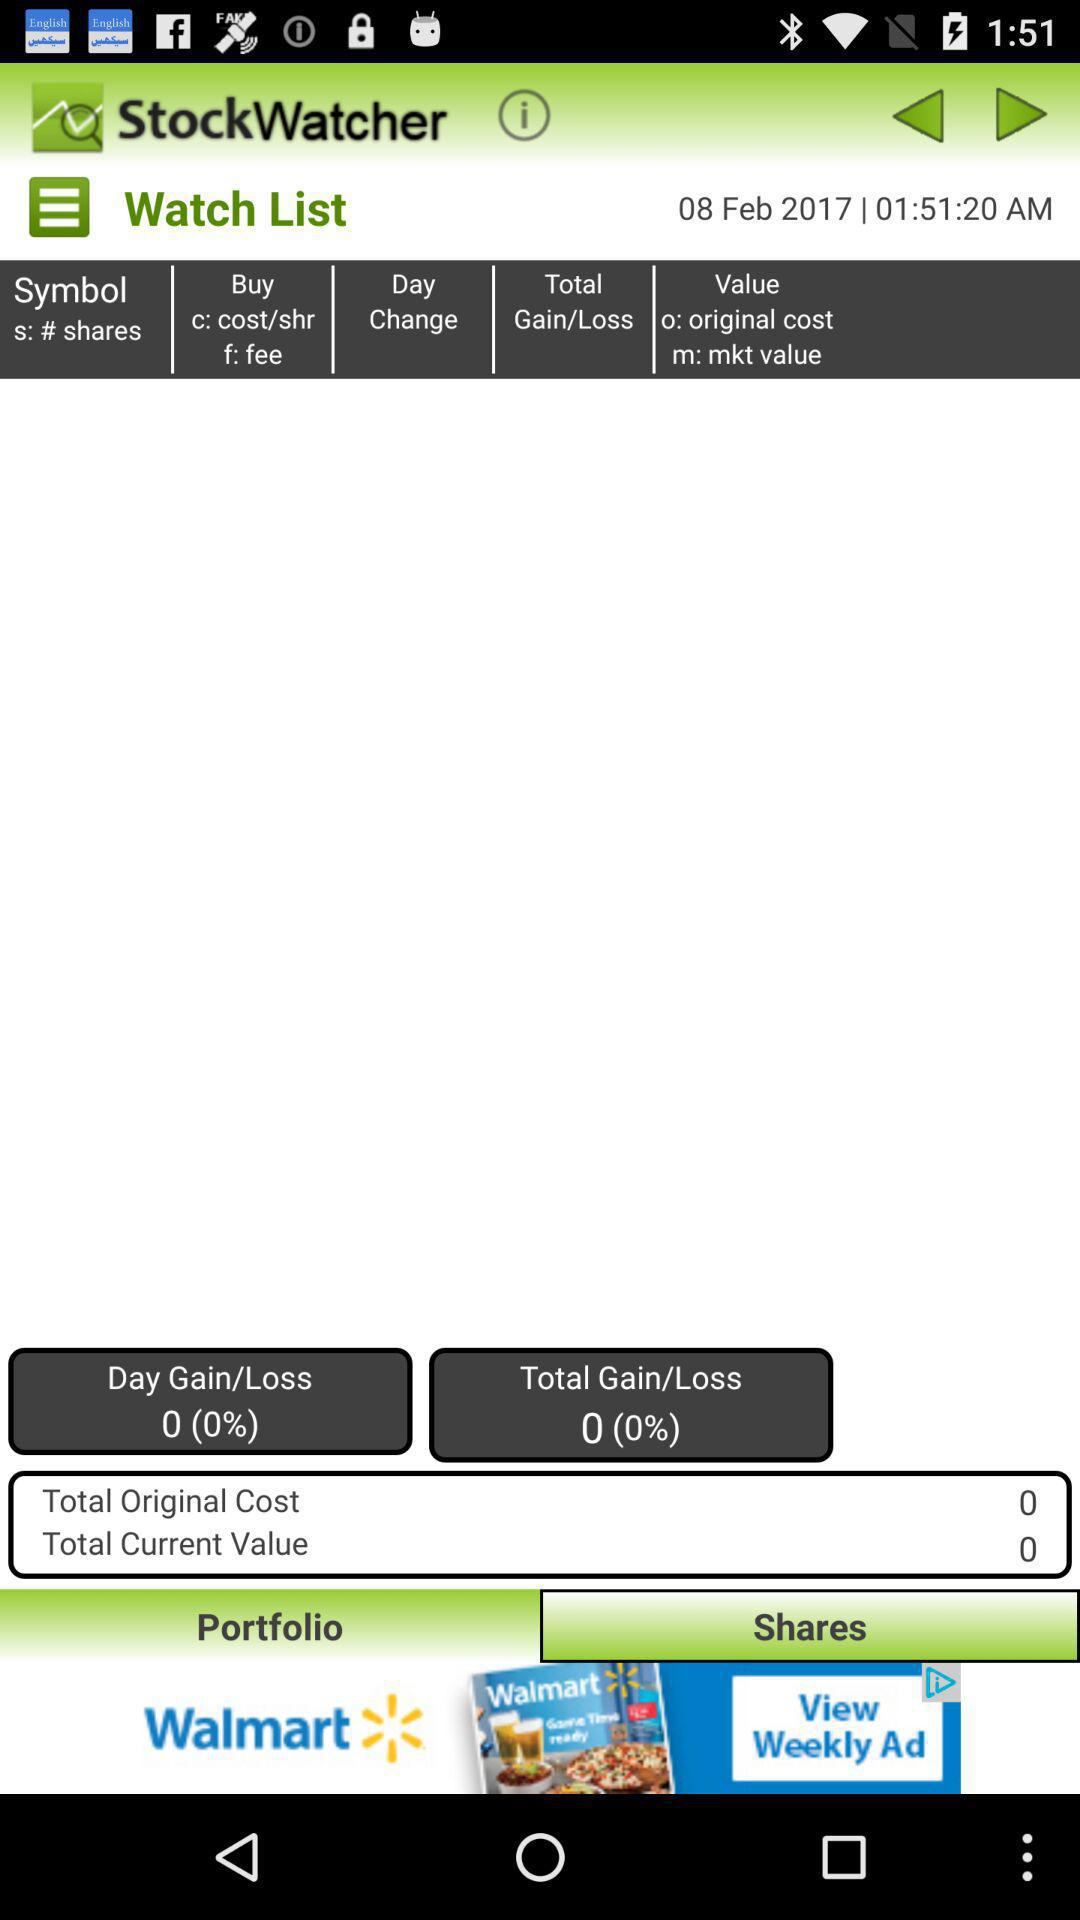What is the name of the application? The name of the application is "StockWatcher". 